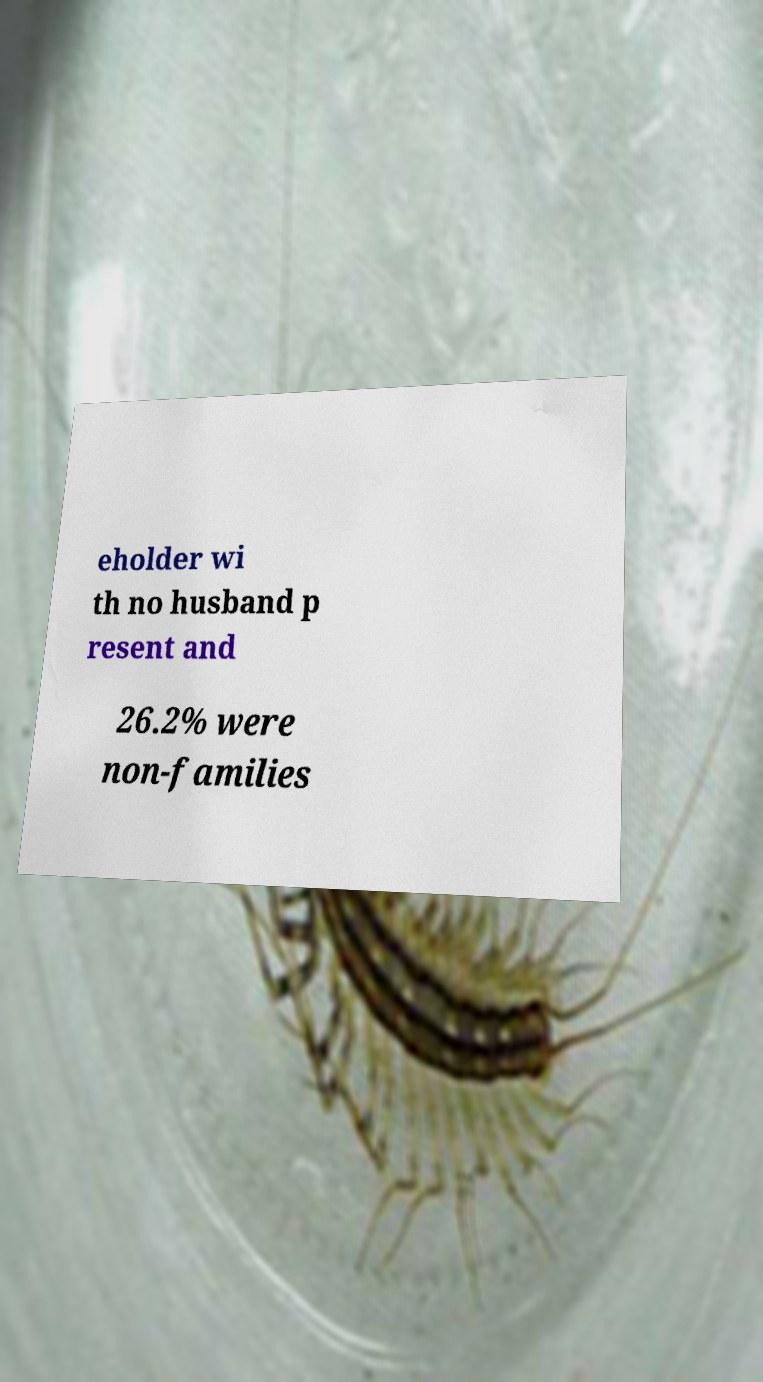Could you extract and type out the text from this image? eholder wi th no husband p resent and 26.2% were non-families 